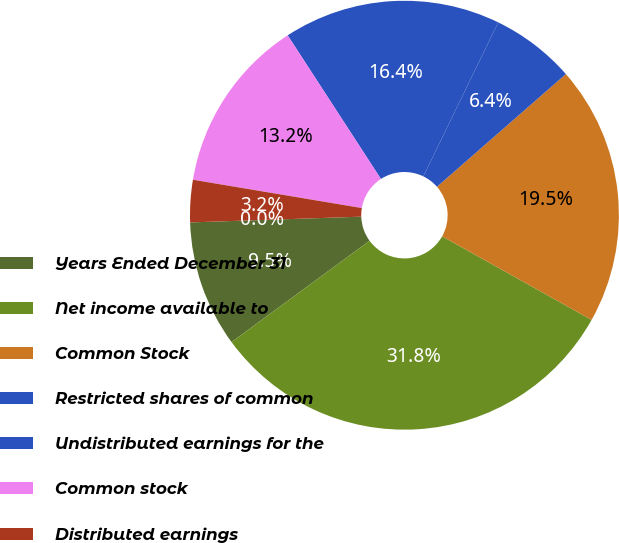Convert chart to OTSL. <chart><loc_0><loc_0><loc_500><loc_500><pie_chart><fcel>Years Ended December 31<fcel>Net income available to<fcel>Common Stock<fcel>Restricted shares of common<fcel>Undistributed earnings for the<fcel>Common stock<fcel>Distributed earnings<fcel>Undistributed earnings<nl><fcel>9.54%<fcel>31.81%<fcel>19.55%<fcel>6.36%<fcel>16.37%<fcel>13.19%<fcel>3.18%<fcel>0.0%<nl></chart> 